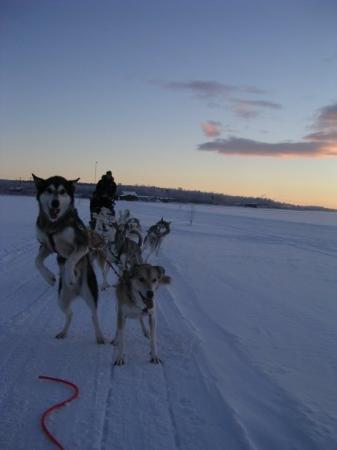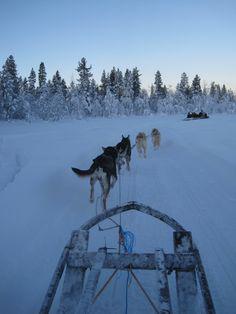The first image is the image on the left, the second image is the image on the right. Assess this claim about the two images: "The sled dogs are resting in one of the images.". Correct or not? Answer yes or no. No. The first image is the image on the left, the second image is the image on the right. Evaluate the accuracy of this statement regarding the images: "An image shows a team of sled dogs headed toward the camera.". Is it true? Answer yes or no. Yes. 